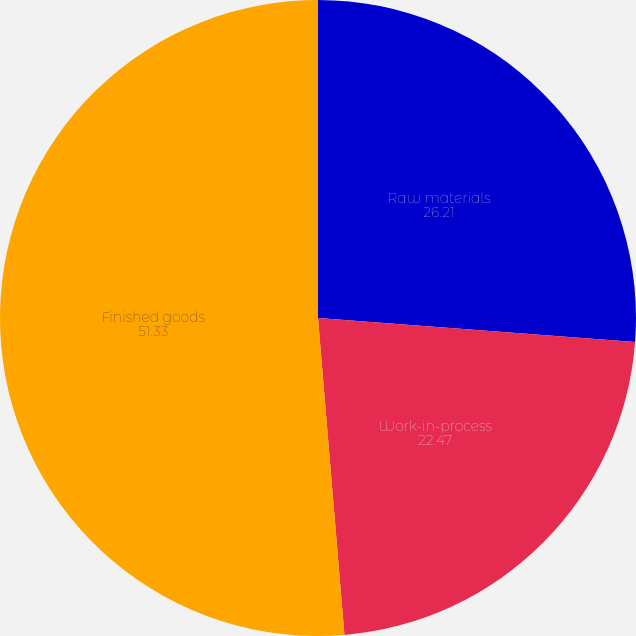Convert chart. <chart><loc_0><loc_0><loc_500><loc_500><pie_chart><fcel>Raw materials<fcel>Work-in-process<fcel>Finished goods<nl><fcel>26.21%<fcel>22.47%<fcel>51.33%<nl></chart> 